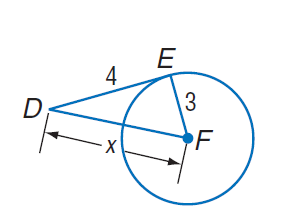Answer the mathemtical geometry problem and directly provide the correct option letter.
Question: E D is tangent to \odot F at point E. Find x.
Choices: A: 3 B: 4 C: 5 D: 6 C 